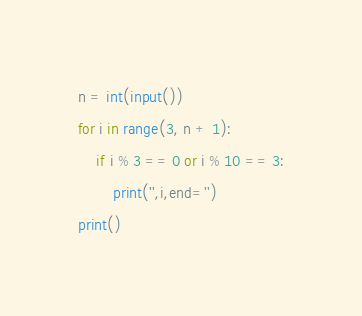Convert code to text. <code><loc_0><loc_0><loc_500><loc_500><_Python_>n = int(input())
for i in range(3, n + 1):
    if i % 3 == 0 or i % 10 == 3:
        print('',i,end='')
print()</code> 